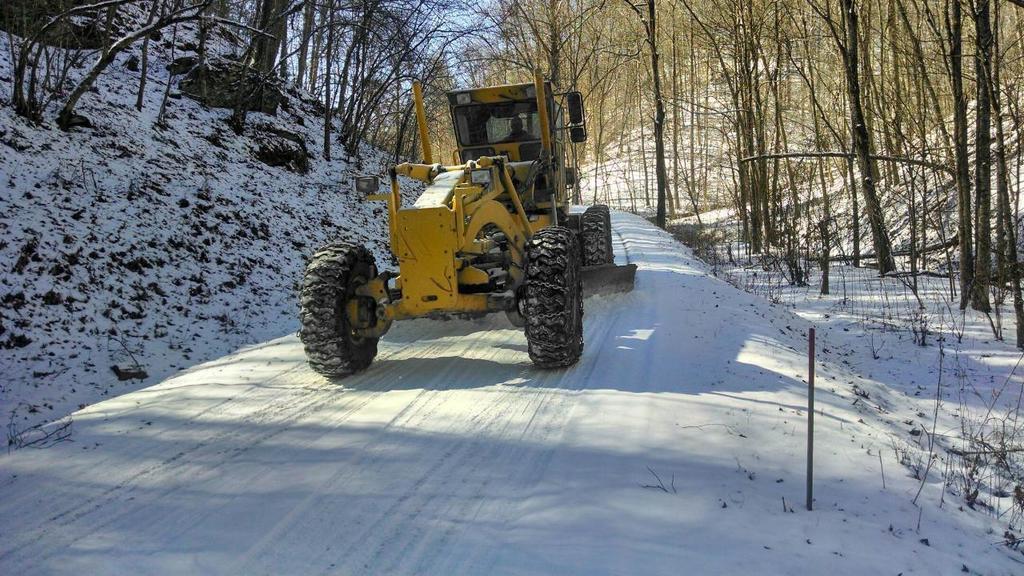Could you give a brief overview of what you see in this image? This picture might be taken from outside of the city and it is sunny. In this image, in the middle, we can see a crane moving on the ice road, in the crane, we can see a person riding. On the right side, we can see some trees. On the left side, we can also see some trees. On the top, we can see a sky, at the bottom there is an ice. 